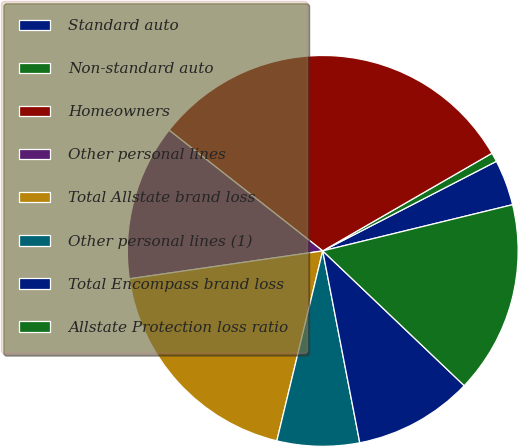<chart> <loc_0><loc_0><loc_500><loc_500><pie_chart><fcel>Standard auto<fcel>Non-standard auto<fcel>Homeowners<fcel>Other personal lines<fcel>Total Allstate brand loss<fcel>Other personal lines (1)<fcel>Total Encompass brand loss<fcel>Allstate Protection loss ratio<nl><fcel>3.78%<fcel>0.75%<fcel>31.07%<fcel>12.88%<fcel>18.94%<fcel>6.81%<fcel>9.85%<fcel>15.91%<nl></chart> 